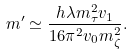Convert formula to latex. <formula><loc_0><loc_0><loc_500><loc_500>m ^ { \prime } \simeq { \frac { h \lambda m _ { \tau } ^ { 2 } v _ { 1 } } { 1 6 \pi ^ { 2 } v _ { 0 } m _ { \zeta } ^ { 2 } } } .</formula> 